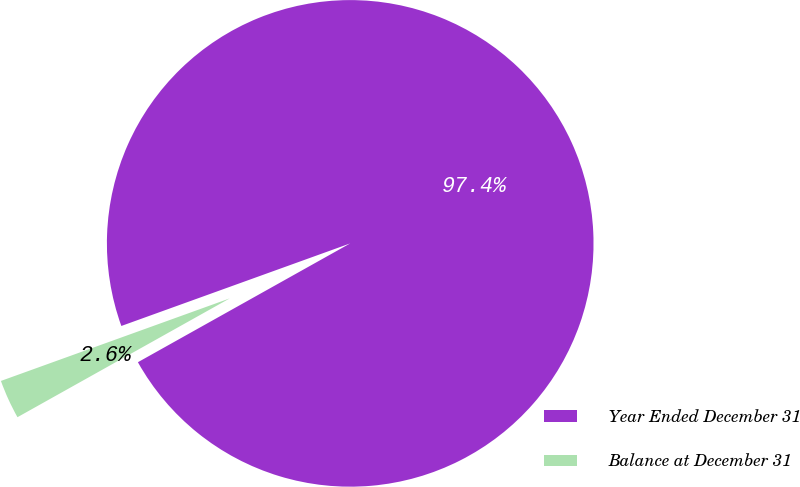Convert chart to OTSL. <chart><loc_0><loc_0><loc_500><loc_500><pie_chart><fcel>Year Ended December 31<fcel>Balance at December 31<nl><fcel>97.39%<fcel>2.61%<nl></chart> 